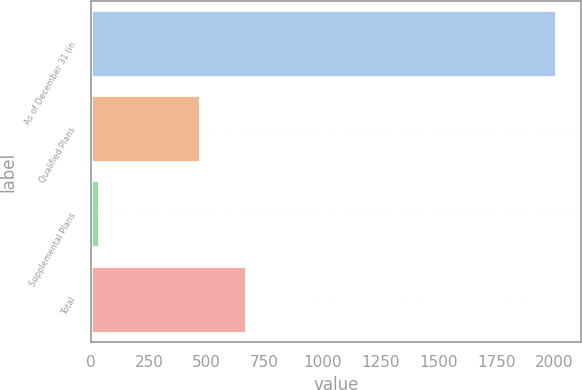Convert chart to OTSL. <chart><loc_0><loc_0><loc_500><loc_500><bar_chart><fcel>As of December 31 (in<fcel>Qualified Plans<fcel>Supplemental Plans<fcel>Total<nl><fcel>2014<fcel>474.8<fcel>40.5<fcel>672.15<nl></chart> 